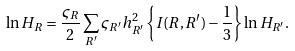<formula> <loc_0><loc_0><loc_500><loc_500>\ln H _ { R } = \frac { \varsigma _ { R } } { 2 } \sum _ { R ^ { \prime } } \varsigma _ { R ^ { \prime } } h _ { R ^ { \prime } } ^ { 2 } \left \{ I ( R , R ^ { \prime } ) - \frac { 1 } { 3 } \right \} \ln H _ { R ^ { \prime } } .</formula> 